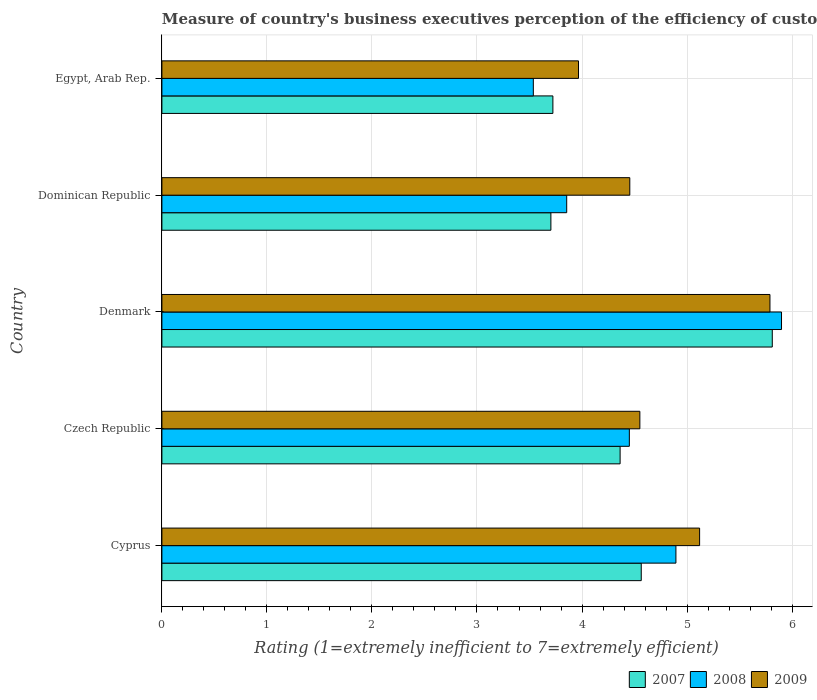How many different coloured bars are there?
Make the answer very short. 3. How many groups of bars are there?
Make the answer very short. 5. Are the number of bars per tick equal to the number of legend labels?
Keep it short and to the point. Yes. How many bars are there on the 2nd tick from the top?
Offer a terse response. 3. What is the label of the 2nd group of bars from the top?
Offer a very short reply. Dominican Republic. What is the rating of the efficiency of customs procedure in 2008 in Dominican Republic?
Your answer should be very brief. 3.85. Across all countries, what is the maximum rating of the efficiency of customs procedure in 2009?
Your response must be concise. 5.79. Across all countries, what is the minimum rating of the efficiency of customs procedure in 2008?
Your response must be concise. 3.54. In which country was the rating of the efficiency of customs procedure in 2008 minimum?
Your answer should be very brief. Egypt, Arab Rep. What is the total rating of the efficiency of customs procedure in 2009 in the graph?
Your answer should be very brief. 23.88. What is the difference between the rating of the efficiency of customs procedure in 2007 in Denmark and that in Egypt, Arab Rep.?
Provide a succinct answer. 2.09. What is the difference between the rating of the efficiency of customs procedure in 2009 in Cyprus and the rating of the efficiency of customs procedure in 2008 in Egypt, Arab Rep.?
Offer a very short reply. 1.58. What is the average rating of the efficiency of customs procedure in 2008 per country?
Give a very brief answer. 4.53. What is the difference between the rating of the efficiency of customs procedure in 2007 and rating of the efficiency of customs procedure in 2008 in Denmark?
Offer a very short reply. -0.09. In how many countries, is the rating of the efficiency of customs procedure in 2009 greater than 2 ?
Offer a very short reply. 5. What is the ratio of the rating of the efficiency of customs procedure in 2008 in Denmark to that in Egypt, Arab Rep.?
Offer a terse response. 1.67. Is the rating of the efficiency of customs procedure in 2007 in Czech Republic less than that in Egypt, Arab Rep.?
Provide a succinct answer. No. Is the difference between the rating of the efficiency of customs procedure in 2007 in Cyprus and Denmark greater than the difference between the rating of the efficiency of customs procedure in 2008 in Cyprus and Denmark?
Ensure brevity in your answer.  No. What is the difference between the highest and the second highest rating of the efficiency of customs procedure in 2009?
Keep it short and to the point. 0.67. What is the difference between the highest and the lowest rating of the efficiency of customs procedure in 2007?
Ensure brevity in your answer.  2.11. In how many countries, is the rating of the efficiency of customs procedure in 2007 greater than the average rating of the efficiency of customs procedure in 2007 taken over all countries?
Provide a succinct answer. 2. Is the sum of the rating of the efficiency of customs procedure in 2007 in Cyprus and Czech Republic greater than the maximum rating of the efficiency of customs procedure in 2009 across all countries?
Provide a short and direct response. Yes. What does the 2nd bar from the bottom in Cyprus represents?
Offer a very short reply. 2008. Is it the case that in every country, the sum of the rating of the efficiency of customs procedure in 2007 and rating of the efficiency of customs procedure in 2009 is greater than the rating of the efficiency of customs procedure in 2008?
Ensure brevity in your answer.  Yes. Are all the bars in the graph horizontal?
Your answer should be compact. Yes. How many countries are there in the graph?
Give a very brief answer. 5. What is the difference between two consecutive major ticks on the X-axis?
Provide a short and direct response. 1. Are the values on the major ticks of X-axis written in scientific E-notation?
Keep it short and to the point. No. How many legend labels are there?
Offer a terse response. 3. How are the legend labels stacked?
Make the answer very short. Horizontal. What is the title of the graph?
Offer a terse response. Measure of country's business executives perception of the efficiency of customs procedures. Does "1960" appear as one of the legend labels in the graph?
Your response must be concise. No. What is the label or title of the X-axis?
Offer a very short reply. Rating (1=extremely inefficient to 7=extremely efficient). What is the label or title of the Y-axis?
Offer a very short reply. Country. What is the Rating (1=extremely inefficient to 7=extremely efficient) of 2007 in Cyprus?
Ensure brevity in your answer.  4.56. What is the Rating (1=extremely inefficient to 7=extremely efficient) in 2008 in Cyprus?
Make the answer very short. 4.89. What is the Rating (1=extremely inefficient to 7=extremely efficient) of 2009 in Cyprus?
Your answer should be compact. 5.12. What is the Rating (1=extremely inefficient to 7=extremely efficient) in 2007 in Czech Republic?
Make the answer very short. 4.36. What is the Rating (1=extremely inefficient to 7=extremely efficient) of 2008 in Czech Republic?
Ensure brevity in your answer.  4.45. What is the Rating (1=extremely inefficient to 7=extremely efficient) of 2009 in Czech Republic?
Offer a very short reply. 4.55. What is the Rating (1=extremely inefficient to 7=extremely efficient) of 2007 in Denmark?
Your answer should be very brief. 5.81. What is the Rating (1=extremely inefficient to 7=extremely efficient) of 2008 in Denmark?
Provide a succinct answer. 5.9. What is the Rating (1=extremely inefficient to 7=extremely efficient) of 2009 in Denmark?
Your answer should be very brief. 5.79. What is the Rating (1=extremely inefficient to 7=extremely efficient) of 2007 in Dominican Republic?
Your answer should be very brief. 3.7. What is the Rating (1=extremely inefficient to 7=extremely efficient) in 2008 in Dominican Republic?
Your answer should be very brief. 3.85. What is the Rating (1=extremely inefficient to 7=extremely efficient) in 2009 in Dominican Republic?
Provide a succinct answer. 4.46. What is the Rating (1=extremely inefficient to 7=extremely efficient) in 2007 in Egypt, Arab Rep.?
Give a very brief answer. 3.72. What is the Rating (1=extremely inefficient to 7=extremely efficient) in 2008 in Egypt, Arab Rep.?
Your answer should be compact. 3.54. What is the Rating (1=extremely inefficient to 7=extremely efficient) of 2009 in Egypt, Arab Rep.?
Offer a very short reply. 3.97. Across all countries, what is the maximum Rating (1=extremely inefficient to 7=extremely efficient) in 2007?
Make the answer very short. 5.81. Across all countries, what is the maximum Rating (1=extremely inefficient to 7=extremely efficient) of 2008?
Your response must be concise. 5.9. Across all countries, what is the maximum Rating (1=extremely inefficient to 7=extremely efficient) of 2009?
Your answer should be compact. 5.79. Across all countries, what is the minimum Rating (1=extremely inefficient to 7=extremely efficient) of 2007?
Keep it short and to the point. 3.7. Across all countries, what is the minimum Rating (1=extremely inefficient to 7=extremely efficient) in 2008?
Keep it short and to the point. 3.54. Across all countries, what is the minimum Rating (1=extremely inefficient to 7=extremely efficient) of 2009?
Give a very brief answer. 3.97. What is the total Rating (1=extremely inefficient to 7=extremely efficient) of 2007 in the graph?
Keep it short and to the point. 22.16. What is the total Rating (1=extremely inefficient to 7=extremely efficient) of 2008 in the graph?
Give a very brief answer. 22.64. What is the total Rating (1=extremely inefficient to 7=extremely efficient) in 2009 in the graph?
Your response must be concise. 23.88. What is the difference between the Rating (1=extremely inefficient to 7=extremely efficient) of 2007 in Cyprus and that in Czech Republic?
Offer a terse response. 0.2. What is the difference between the Rating (1=extremely inefficient to 7=extremely efficient) of 2008 in Cyprus and that in Czech Republic?
Provide a succinct answer. 0.44. What is the difference between the Rating (1=extremely inefficient to 7=extremely efficient) in 2009 in Cyprus and that in Czech Republic?
Provide a succinct answer. 0.57. What is the difference between the Rating (1=extremely inefficient to 7=extremely efficient) in 2007 in Cyprus and that in Denmark?
Keep it short and to the point. -1.25. What is the difference between the Rating (1=extremely inefficient to 7=extremely efficient) in 2008 in Cyprus and that in Denmark?
Ensure brevity in your answer.  -1.01. What is the difference between the Rating (1=extremely inefficient to 7=extremely efficient) in 2009 in Cyprus and that in Denmark?
Keep it short and to the point. -0.67. What is the difference between the Rating (1=extremely inefficient to 7=extremely efficient) in 2007 in Cyprus and that in Dominican Republic?
Give a very brief answer. 0.86. What is the difference between the Rating (1=extremely inefficient to 7=extremely efficient) of 2008 in Cyprus and that in Dominican Republic?
Keep it short and to the point. 1.04. What is the difference between the Rating (1=extremely inefficient to 7=extremely efficient) in 2009 in Cyprus and that in Dominican Republic?
Make the answer very short. 0.66. What is the difference between the Rating (1=extremely inefficient to 7=extremely efficient) of 2007 in Cyprus and that in Egypt, Arab Rep.?
Provide a succinct answer. 0.84. What is the difference between the Rating (1=extremely inefficient to 7=extremely efficient) of 2008 in Cyprus and that in Egypt, Arab Rep.?
Your response must be concise. 1.36. What is the difference between the Rating (1=extremely inefficient to 7=extremely efficient) in 2009 in Cyprus and that in Egypt, Arab Rep.?
Make the answer very short. 1.15. What is the difference between the Rating (1=extremely inefficient to 7=extremely efficient) in 2007 in Czech Republic and that in Denmark?
Offer a very short reply. -1.45. What is the difference between the Rating (1=extremely inefficient to 7=extremely efficient) in 2008 in Czech Republic and that in Denmark?
Offer a very short reply. -1.45. What is the difference between the Rating (1=extremely inefficient to 7=extremely efficient) of 2009 in Czech Republic and that in Denmark?
Offer a terse response. -1.24. What is the difference between the Rating (1=extremely inefficient to 7=extremely efficient) in 2007 in Czech Republic and that in Dominican Republic?
Your response must be concise. 0.66. What is the difference between the Rating (1=extremely inefficient to 7=extremely efficient) in 2008 in Czech Republic and that in Dominican Republic?
Your answer should be very brief. 0.6. What is the difference between the Rating (1=extremely inefficient to 7=extremely efficient) of 2009 in Czech Republic and that in Dominican Republic?
Keep it short and to the point. 0.1. What is the difference between the Rating (1=extremely inefficient to 7=extremely efficient) of 2007 in Czech Republic and that in Egypt, Arab Rep.?
Provide a short and direct response. 0.64. What is the difference between the Rating (1=extremely inefficient to 7=extremely efficient) of 2008 in Czech Republic and that in Egypt, Arab Rep.?
Make the answer very short. 0.91. What is the difference between the Rating (1=extremely inefficient to 7=extremely efficient) in 2009 in Czech Republic and that in Egypt, Arab Rep.?
Ensure brevity in your answer.  0.58. What is the difference between the Rating (1=extremely inefficient to 7=extremely efficient) of 2007 in Denmark and that in Dominican Republic?
Make the answer very short. 2.11. What is the difference between the Rating (1=extremely inefficient to 7=extremely efficient) in 2008 in Denmark and that in Dominican Republic?
Provide a short and direct response. 2.05. What is the difference between the Rating (1=extremely inefficient to 7=extremely efficient) in 2009 in Denmark and that in Dominican Republic?
Your answer should be very brief. 1.33. What is the difference between the Rating (1=extremely inefficient to 7=extremely efficient) in 2007 in Denmark and that in Egypt, Arab Rep.?
Your answer should be very brief. 2.09. What is the difference between the Rating (1=extremely inefficient to 7=extremely efficient) of 2008 in Denmark and that in Egypt, Arab Rep.?
Offer a terse response. 2.36. What is the difference between the Rating (1=extremely inefficient to 7=extremely efficient) of 2009 in Denmark and that in Egypt, Arab Rep.?
Your answer should be compact. 1.82. What is the difference between the Rating (1=extremely inefficient to 7=extremely efficient) of 2007 in Dominican Republic and that in Egypt, Arab Rep.?
Give a very brief answer. -0.02. What is the difference between the Rating (1=extremely inefficient to 7=extremely efficient) in 2008 in Dominican Republic and that in Egypt, Arab Rep.?
Ensure brevity in your answer.  0.32. What is the difference between the Rating (1=extremely inefficient to 7=extremely efficient) of 2009 in Dominican Republic and that in Egypt, Arab Rep.?
Your response must be concise. 0.49. What is the difference between the Rating (1=extremely inefficient to 7=extremely efficient) in 2007 in Cyprus and the Rating (1=extremely inefficient to 7=extremely efficient) in 2008 in Czech Republic?
Your answer should be compact. 0.11. What is the difference between the Rating (1=extremely inefficient to 7=extremely efficient) of 2007 in Cyprus and the Rating (1=extremely inefficient to 7=extremely efficient) of 2009 in Czech Republic?
Your answer should be very brief. 0.01. What is the difference between the Rating (1=extremely inefficient to 7=extremely efficient) in 2008 in Cyprus and the Rating (1=extremely inefficient to 7=extremely efficient) in 2009 in Czech Republic?
Your answer should be very brief. 0.34. What is the difference between the Rating (1=extremely inefficient to 7=extremely efficient) of 2007 in Cyprus and the Rating (1=extremely inefficient to 7=extremely efficient) of 2008 in Denmark?
Your response must be concise. -1.34. What is the difference between the Rating (1=extremely inefficient to 7=extremely efficient) in 2007 in Cyprus and the Rating (1=extremely inefficient to 7=extremely efficient) in 2009 in Denmark?
Offer a terse response. -1.23. What is the difference between the Rating (1=extremely inefficient to 7=extremely efficient) in 2008 in Cyprus and the Rating (1=extremely inefficient to 7=extremely efficient) in 2009 in Denmark?
Make the answer very short. -0.9. What is the difference between the Rating (1=extremely inefficient to 7=extremely efficient) of 2007 in Cyprus and the Rating (1=extremely inefficient to 7=extremely efficient) of 2008 in Dominican Republic?
Keep it short and to the point. 0.71. What is the difference between the Rating (1=extremely inefficient to 7=extremely efficient) in 2007 in Cyprus and the Rating (1=extremely inefficient to 7=extremely efficient) in 2009 in Dominican Republic?
Ensure brevity in your answer.  0.11. What is the difference between the Rating (1=extremely inefficient to 7=extremely efficient) in 2008 in Cyprus and the Rating (1=extremely inefficient to 7=extremely efficient) in 2009 in Dominican Republic?
Ensure brevity in your answer.  0.44. What is the difference between the Rating (1=extremely inefficient to 7=extremely efficient) of 2007 in Cyprus and the Rating (1=extremely inefficient to 7=extremely efficient) of 2008 in Egypt, Arab Rep.?
Keep it short and to the point. 1.03. What is the difference between the Rating (1=extremely inefficient to 7=extremely efficient) of 2007 in Cyprus and the Rating (1=extremely inefficient to 7=extremely efficient) of 2009 in Egypt, Arab Rep.?
Provide a succinct answer. 0.6. What is the difference between the Rating (1=extremely inefficient to 7=extremely efficient) in 2008 in Cyprus and the Rating (1=extremely inefficient to 7=extremely efficient) in 2009 in Egypt, Arab Rep.?
Provide a succinct answer. 0.93. What is the difference between the Rating (1=extremely inefficient to 7=extremely efficient) in 2007 in Czech Republic and the Rating (1=extremely inefficient to 7=extremely efficient) in 2008 in Denmark?
Your answer should be compact. -1.54. What is the difference between the Rating (1=extremely inefficient to 7=extremely efficient) of 2007 in Czech Republic and the Rating (1=extremely inefficient to 7=extremely efficient) of 2009 in Denmark?
Provide a succinct answer. -1.43. What is the difference between the Rating (1=extremely inefficient to 7=extremely efficient) in 2008 in Czech Republic and the Rating (1=extremely inefficient to 7=extremely efficient) in 2009 in Denmark?
Keep it short and to the point. -1.34. What is the difference between the Rating (1=extremely inefficient to 7=extremely efficient) of 2007 in Czech Republic and the Rating (1=extremely inefficient to 7=extremely efficient) of 2008 in Dominican Republic?
Give a very brief answer. 0.51. What is the difference between the Rating (1=extremely inefficient to 7=extremely efficient) in 2007 in Czech Republic and the Rating (1=extremely inefficient to 7=extremely efficient) in 2009 in Dominican Republic?
Offer a very short reply. -0.09. What is the difference between the Rating (1=extremely inefficient to 7=extremely efficient) in 2008 in Czech Republic and the Rating (1=extremely inefficient to 7=extremely efficient) in 2009 in Dominican Republic?
Offer a very short reply. -0. What is the difference between the Rating (1=extremely inefficient to 7=extremely efficient) in 2007 in Czech Republic and the Rating (1=extremely inefficient to 7=extremely efficient) in 2008 in Egypt, Arab Rep.?
Ensure brevity in your answer.  0.83. What is the difference between the Rating (1=extremely inefficient to 7=extremely efficient) of 2007 in Czech Republic and the Rating (1=extremely inefficient to 7=extremely efficient) of 2009 in Egypt, Arab Rep.?
Offer a very short reply. 0.4. What is the difference between the Rating (1=extremely inefficient to 7=extremely efficient) in 2008 in Czech Republic and the Rating (1=extremely inefficient to 7=extremely efficient) in 2009 in Egypt, Arab Rep.?
Your response must be concise. 0.48. What is the difference between the Rating (1=extremely inefficient to 7=extremely efficient) in 2007 in Denmark and the Rating (1=extremely inefficient to 7=extremely efficient) in 2008 in Dominican Republic?
Offer a very short reply. 1.96. What is the difference between the Rating (1=extremely inefficient to 7=extremely efficient) of 2007 in Denmark and the Rating (1=extremely inefficient to 7=extremely efficient) of 2009 in Dominican Republic?
Offer a terse response. 1.36. What is the difference between the Rating (1=extremely inefficient to 7=extremely efficient) in 2008 in Denmark and the Rating (1=extremely inefficient to 7=extremely efficient) in 2009 in Dominican Republic?
Provide a short and direct response. 1.44. What is the difference between the Rating (1=extremely inefficient to 7=extremely efficient) of 2007 in Denmark and the Rating (1=extremely inefficient to 7=extremely efficient) of 2008 in Egypt, Arab Rep.?
Make the answer very short. 2.28. What is the difference between the Rating (1=extremely inefficient to 7=extremely efficient) of 2007 in Denmark and the Rating (1=extremely inefficient to 7=extremely efficient) of 2009 in Egypt, Arab Rep.?
Provide a short and direct response. 1.84. What is the difference between the Rating (1=extremely inefficient to 7=extremely efficient) of 2008 in Denmark and the Rating (1=extremely inefficient to 7=extremely efficient) of 2009 in Egypt, Arab Rep.?
Make the answer very short. 1.93. What is the difference between the Rating (1=extremely inefficient to 7=extremely efficient) of 2007 in Dominican Republic and the Rating (1=extremely inefficient to 7=extremely efficient) of 2008 in Egypt, Arab Rep.?
Make the answer very short. 0.17. What is the difference between the Rating (1=extremely inefficient to 7=extremely efficient) in 2007 in Dominican Republic and the Rating (1=extremely inefficient to 7=extremely efficient) in 2009 in Egypt, Arab Rep.?
Offer a very short reply. -0.26. What is the difference between the Rating (1=extremely inefficient to 7=extremely efficient) of 2008 in Dominican Republic and the Rating (1=extremely inefficient to 7=extremely efficient) of 2009 in Egypt, Arab Rep.?
Provide a short and direct response. -0.11. What is the average Rating (1=extremely inefficient to 7=extremely efficient) in 2007 per country?
Keep it short and to the point. 4.43. What is the average Rating (1=extremely inefficient to 7=extremely efficient) of 2008 per country?
Keep it short and to the point. 4.53. What is the average Rating (1=extremely inefficient to 7=extremely efficient) in 2009 per country?
Provide a succinct answer. 4.78. What is the difference between the Rating (1=extremely inefficient to 7=extremely efficient) in 2007 and Rating (1=extremely inefficient to 7=extremely efficient) in 2008 in Cyprus?
Your answer should be very brief. -0.33. What is the difference between the Rating (1=extremely inefficient to 7=extremely efficient) of 2007 and Rating (1=extremely inefficient to 7=extremely efficient) of 2009 in Cyprus?
Keep it short and to the point. -0.56. What is the difference between the Rating (1=extremely inefficient to 7=extremely efficient) of 2008 and Rating (1=extremely inefficient to 7=extremely efficient) of 2009 in Cyprus?
Ensure brevity in your answer.  -0.23. What is the difference between the Rating (1=extremely inefficient to 7=extremely efficient) of 2007 and Rating (1=extremely inefficient to 7=extremely efficient) of 2008 in Czech Republic?
Your response must be concise. -0.09. What is the difference between the Rating (1=extremely inefficient to 7=extremely efficient) in 2007 and Rating (1=extremely inefficient to 7=extremely efficient) in 2009 in Czech Republic?
Provide a short and direct response. -0.19. What is the difference between the Rating (1=extremely inefficient to 7=extremely efficient) in 2008 and Rating (1=extremely inefficient to 7=extremely efficient) in 2009 in Czech Republic?
Provide a short and direct response. -0.1. What is the difference between the Rating (1=extremely inefficient to 7=extremely efficient) of 2007 and Rating (1=extremely inefficient to 7=extremely efficient) of 2008 in Denmark?
Make the answer very short. -0.09. What is the difference between the Rating (1=extremely inefficient to 7=extremely efficient) in 2007 and Rating (1=extremely inefficient to 7=extremely efficient) in 2009 in Denmark?
Your answer should be very brief. 0.02. What is the difference between the Rating (1=extremely inefficient to 7=extremely efficient) of 2008 and Rating (1=extremely inefficient to 7=extremely efficient) of 2009 in Denmark?
Your answer should be very brief. 0.11. What is the difference between the Rating (1=extremely inefficient to 7=extremely efficient) in 2007 and Rating (1=extremely inefficient to 7=extremely efficient) in 2008 in Dominican Republic?
Your response must be concise. -0.15. What is the difference between the Rating (1=extremely inefficient to 7=extremely efficient) in 2007 and Rating (1=extremely inefficient to 7=extremely efficient) in 2009 in Dominican Republic?
Offer a terse response. -0.75. What is the difference between the Rating (1=extremely inefficient to 7=extremely efficient) in 2008 and Rating (1=extremely inefficient to 7=extremely efficient) in 2009 in Dominican Republic?
Your answer should be very brief. -0.6. What is the difference between the Rating (1=extremely inefficient to 7=extremely efficient) of 2007 and Rating (1=extremely inefficient to 7=extremely efficient) of 2008 in Egypt, Arab Rep.?
Offer a very short reply. 0.19. What is the difference between the Rating (1=extremely inefficient to 7=extremely efficient) of 2007 and Rating (1=extremely inefficient to 7=extremely efficient) of 2009 in Egypt, Arab Rep.?
Your response must be concise. -0.24. What is the difference between the Rating (1=extremely inefficient to 7=extremely efficient) in 2008 and Rating (1=extremely inefficient to 7=extremely efficient) in 2009 in Egypt, Arab Rep.?
Provide a short and direct response. -0.43. What is the ratio of the Rating (1=extremely inefficient to 7=extremely efficient) in 2007 in Cyprus to that in Czech Republic?
Keep it short and to the point. 1.05. What is the ratio of the Rating (1=extremely inefficient to 7=extremely efficient) in 2008 in Cyprus to that in Czech Republic?
Offer a terse response. 1.1. What is the ratio of the Rating (1=extremely inefficient to 7=extremely efficient) of 2007 in Cyprus to that in Denmark?
Make the answer very short. 0.79. What is the ratio of the Rating (1=extremely inefficient to 7=extremely efficient) of 2008 in Cyprus to that in Denmark?
Ensure brevity in your answer.  0.83. What is the ratio of the Rating (1=extremely inefficient to 7=extremely efficient) of 2009 in Cyprus to that in Denmark?
Provide a short and direct response. 0.88. What is the ratio of the Rating (1=extremely inefficient to 7=extremely efficient) in 2007 in Cyprus to that in Dominican Republic?
Provide a short and direct response. 1.23. What is the ratio of the Rating (1=extremely inefficient to 7=extremely efficient) of 2008 in Cyprus to that in Dominican Republic?
Make the answer very short. 1.27. What is the ratio of the Rating (1=extremely inefficient to 7=extremely efficient) of 2009 in Cyprus to that in Dominican Republic?
Offer a terse response. 1.15. What is the ratio of the Rating (1=extremely inefficient to 7=extremely efficient) in 2007 in Cyprus to that in Egypt, Arab Rep.?
Ensure brevity in your answer.  1.23. What is the ratio of the Rating (1=extremely inefficient to 7=extremely efficient) of 2008 in Cyprus to that in Egypt, Arab Rep.?
Offer a very short reply. 1.38. What is the ratio of the Rating (1=extremely inefficient to 7=extremely efficient) of 2009 in Cyprus to that in Egypt, Arab Rep.?
Offer a terse response. 1.29. What is the ratio of the Rating (1=extremely inefficient to 7=extremely efficient) in 2007 in Czech Republic to that in Denmark?
Provide a succinct answer. 0.75. What is the ratio of the Rating (1=extremely inefficient to 7=extremely efficient) of 2008 in Czech Republic to that in Denmark?
Your answer should be very brief. 0.75. What is the ratio of the Rating (1=extremely inefficient to 7=extremely efficient) of 2009 in Czech Republic to that in Denmark?
Your response must be concise. 0.79. What is the ratio of the Rating (1=extremely inefficient to 7=extremely efficient) of 2007 in Czech Republic to that in Dominican Republic?
Ensure brevity in your answer.  1.18. What is the ratio of the Rating (1=extremely inefficient to 7=extremely efficient) in 2008 in Czech Republic to that in Dominican Republic?
Provide a short and direct response. 1.15. What is the ratio of the Rating (1=extremely inefficient to 7=extremely efficient) of 2009 in Czech Republic to that in Dominican Republic?
Provide a short and direct response. 1.02. What is the ratio of the Rating (1=extremely inefficient to 7=extremely efficient) in 2007 in Czech Republic to that in Egypt, Arab Rep.?
Offer a terse response. 1.17. What is the ratio of the Rating (1=extremely inefficient to 7=extremely efficient) in 2008 in Czech Republic to that in Egypt, Arab Rep.?
Provide a succinct answer. 1.26. What is the ratio of the Rating (1=extremely inefficient to 7=extremely efficient) in 2009 in Czech Republic to that in Egypt, Arab Rep.?
Give a very brief answer. 1.15. What is the ratio of the Rating (1=extremely inefficient to 7=extremely efficient) of 2007 in Denmark to that in Dominican Republic?
Make the answer very short. 1.57. What is the ratio of the Rating (1=extremely inefficient to 7=extremely efficient) in 2008 in Denmark to that in Dominican Republic?
Make the answer very short. 1.53. What is the ratio of the Rating (1=extremely inefficient to 7=extremely efficient) in 2009 in Denmark to that in Dominican Republic?
Your answer should be very brief. 1.3. What is the ratio of the Rating (1=extremely inefficient to 7=extremely efficient) of 2007 in Denmark to that in Egypt, Arab Rep.?
Your answer should be compact. 1.56. What is the ratio of the Rating (1=extremely inefficient to 7=extremely efficient) of 2008 in Denmark to that in Egypt, Arab Rep.?
Your answer should be compact. 1.67. What is the ratio of the Rating (1=extremely inefficient to 7=extremely efficient) of 2009 in Denmark to that in Egypt, Arab Rep.?
Your answer should be compact. 1.46. What is the ratio of the Rating (1=extremely inefficient to 7=extremely efficient) in 2008 in Dominican Republic to that in Egypt, Arab Rep.?
Your answer should be very brief. 1.09. What is the ratio of the Rating (1=extremely inefficient to 7=extremely efficient) of 2009 in Dominican Republic to that in Egypt, Arab Rep.?
Make the answer very short. 1.12. What is the difference between the highest and the second highest Rating (1=extremely inefficient to 7=extremely efficient) in 2007?
Offer a terse response. 1.25. What is the difference between the highest and the second highest Rating (1=extremely inefficient to 7=extremely efficient) in 2008?
Keep it short and to the point. 1.01. What is the difference between the highest and the second highest Rating (1=extremely inefficient to 7=extremely efficient) in 2009?
Make the answer very short. 0.67. What is the difference between the highest and the lowest Rating (1=extremely inefficient to 7=extremely efficient) in 2007?
Make the answer very short. 2.11. What is the difference between the highest and the lowest Rating (1=extremely inefficient to 7=extremely efficient) in 2008?
Your response must be concise. 2.36. What is the difference between the highest and the lowest Rating (1=extremely inefficient to 7=extremely efficient) in 2009?
Provide a succinct answer. 1.82. 